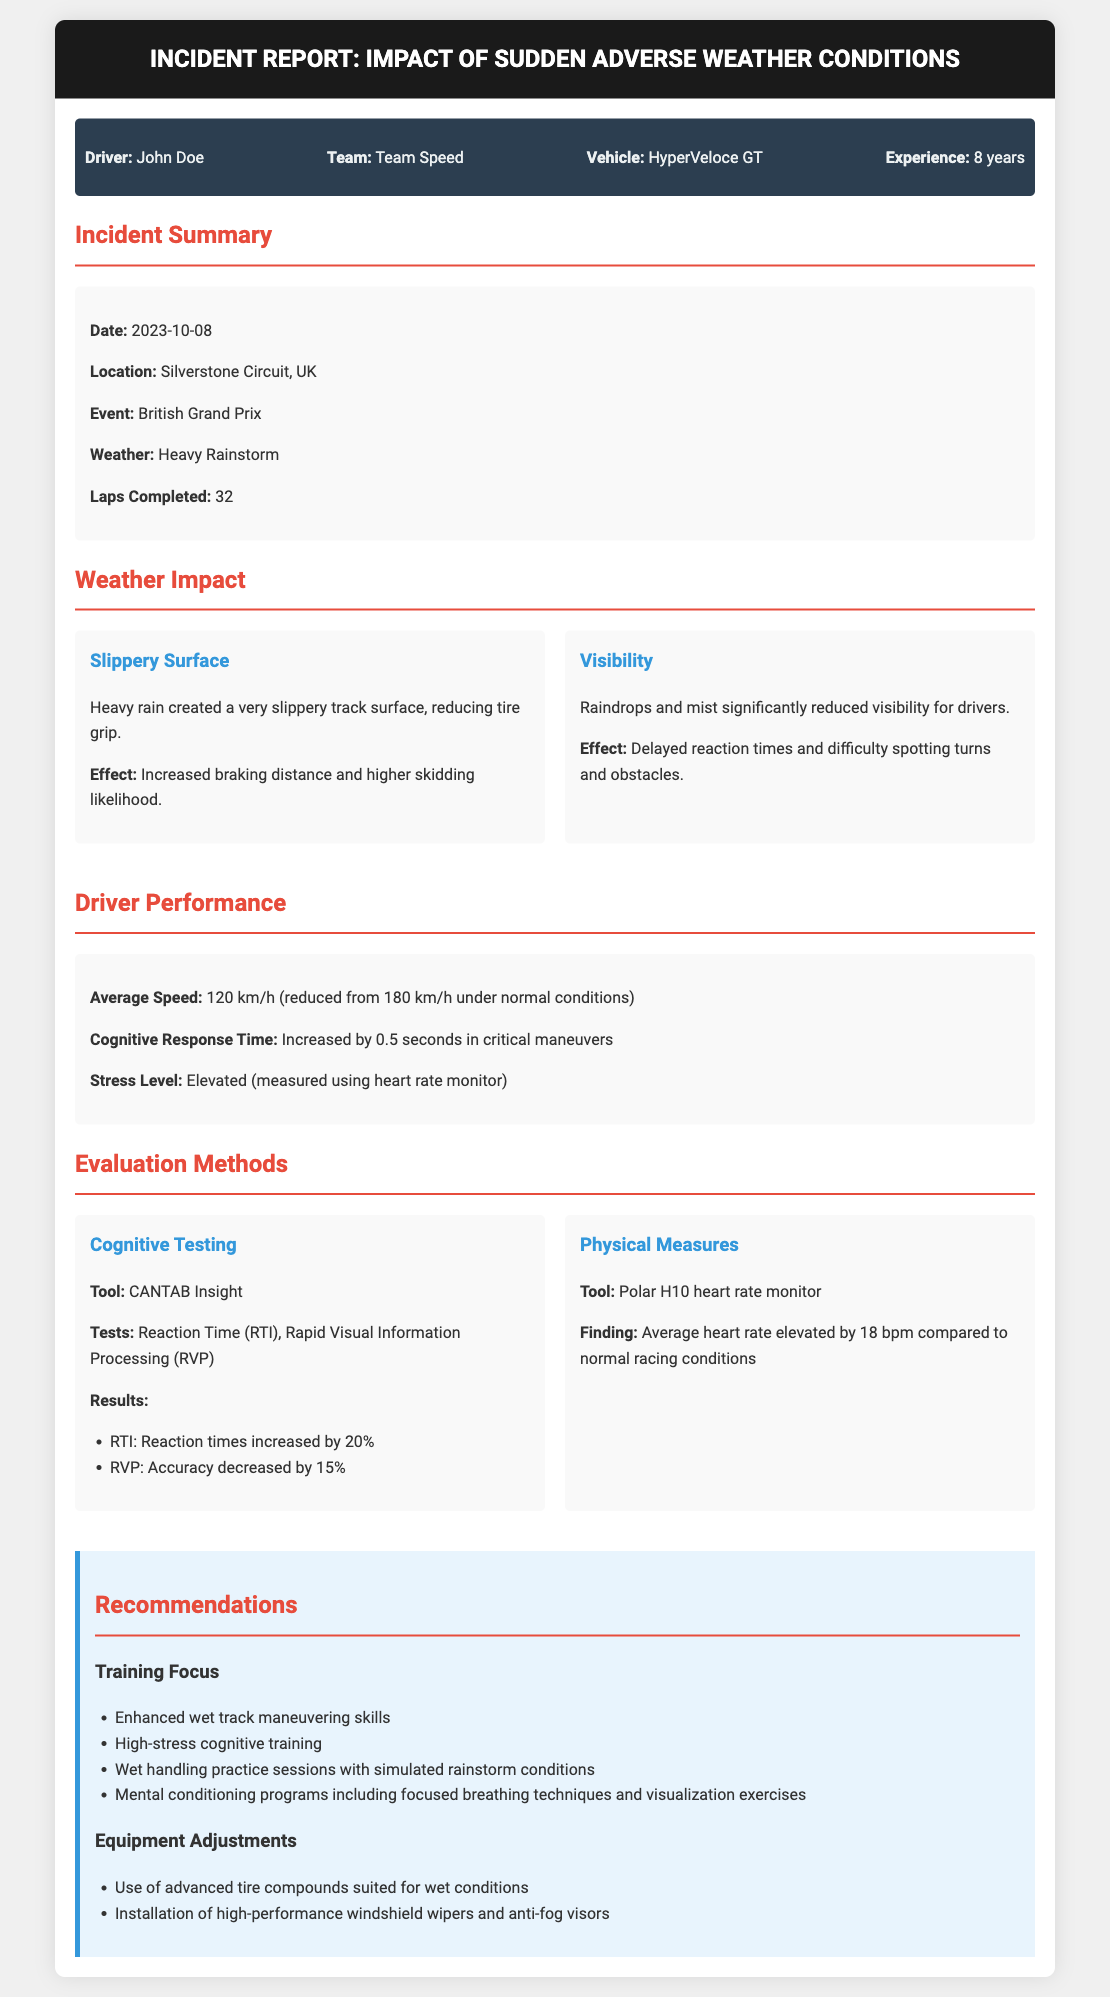What is the driver's name? The driver's name is provided in the driver info section of the report.
Answer: John Doe What was the date of the incident? The date is mentioned in the incident summary section of the report.
Answer: 2023-10-08 What weather condition affected the race? The weather condition is specified in the incident summary section.
Answer: Heavy Rainstorm What was the average speed during the incident? The average speed is detailed in the driver performance section of the report.
Answer: 120 km/h How much did cognitive response time increase? The increase in cognitive response time is provided in the driver performance section.
Answer: 0.5 seconds Which cognitive testing tool was used? The tool used for cognitive testing is listed in the evaluation methods section.
Answer: CANTAB Insight What was the average heart rate elevation compared to normal racing conditions? The heart rate elevation is mentioned in the physical measures section of the report.
Answer: 18 bpm What training focus is recommended for the driver? The recommendations for training focus can be found in the recommendations section.
Answer: Enhanced wet track maneuvering skills How many laps were completed during the race? The total laps completed is stated in the incident summary section of the report.
Answer: 32 Which vehicle did the driver use? The vehicle used by the driver is specified in the driver info section.
Answer: HyperVeloce GT 